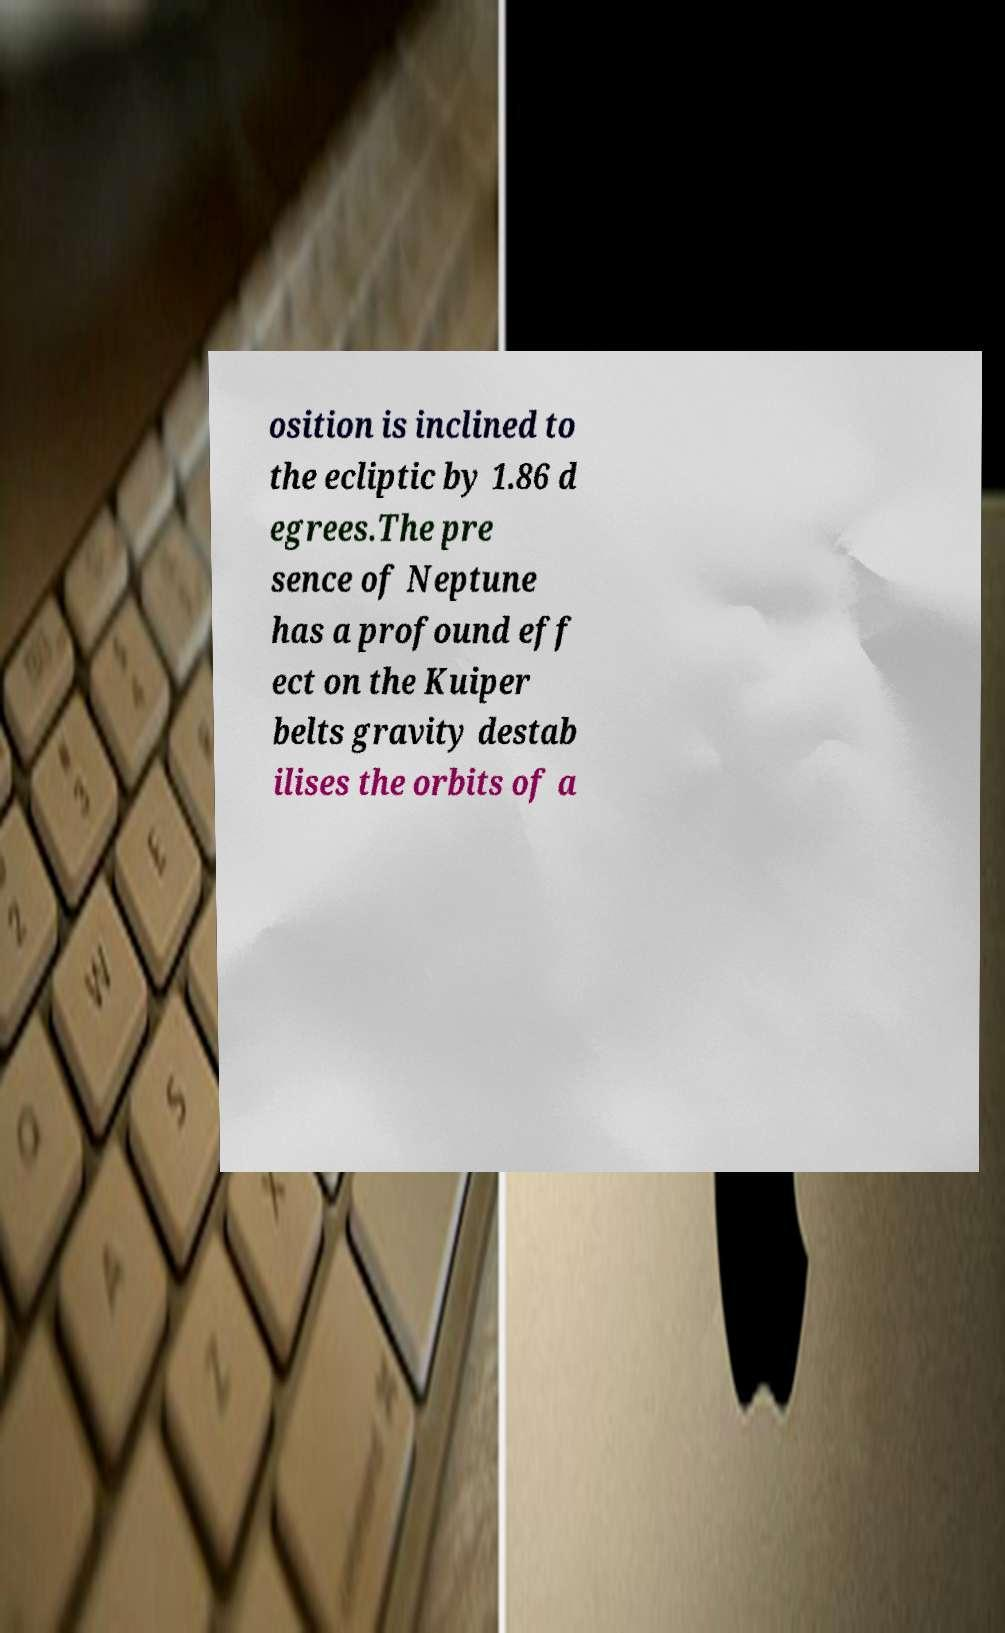Please read and relay the text visible in this image. What does it say? osition is inclined to the ecliptic by 1.86 d egrees.The pre sence of Neptune has a profound eff ect on the Kuiper belts gravity destab ilises the orbits of a 